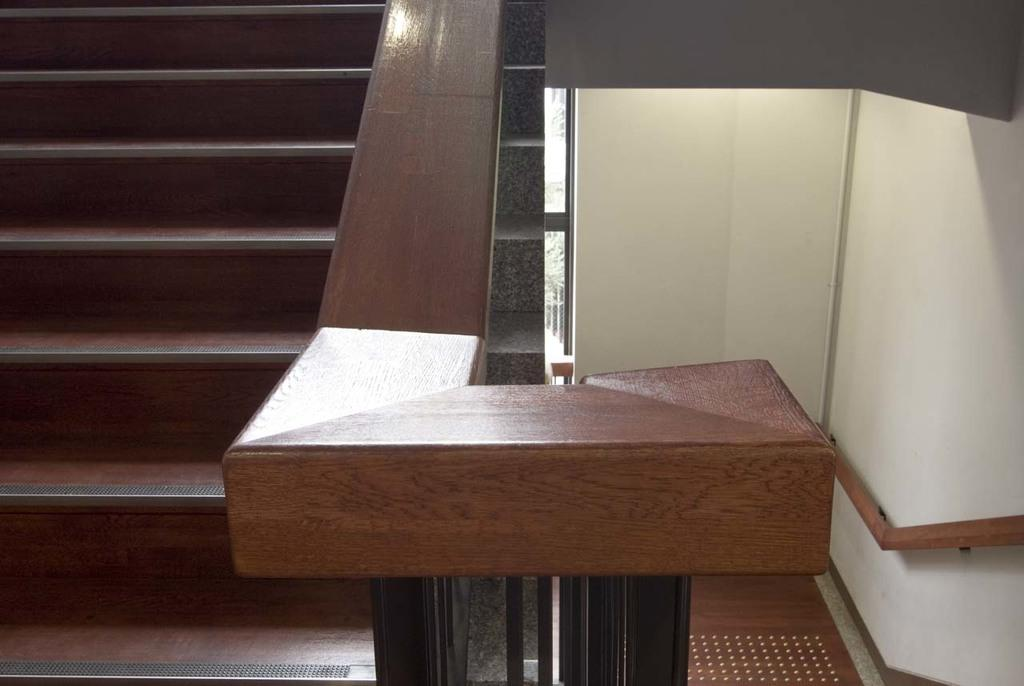What type of structure is located on the left side of the image? There are stairs on the left side of the image. What can be seen in the center of the image? There is a wooden pole in the center of the image. What is on the right side of the image? There is a wall on the right side of the image. What sense is being expressed by the wooden pole in the image? The wooden pole does not express any sense; it is an inanimate object. 